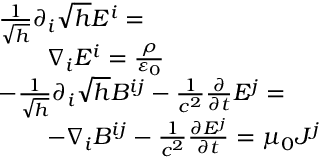Convert formula to latex. <formula><loc_0><loc_0><loc_500><loc_500>{ \begin{array} { r l } & { { \frac { 1 } { \sqrt { h } } } \partial _ { i } { \sqrt { h } } E ^ { i } = } \\ & { \quad \nabla _ { i } E ^ { i } = { \frac { \rho } { \varepsilon _ { 0 } } } } \\ & { { - } { \frac { 1 } { \sqrt { h } } } \partial _ { i } { \sqrt { h } } B ^ { i j } - { \frac { 1 } { c ^ { 2 } } } { \frac { \partial } { \partial t } } E ^ { j } = } \\ & { \quad { - } \nabla _ { i } B ^ { i j } - { \frac { 1 } { c ^ { 2 } } } { \frac { \partial E ^ { j } } { \partial t } } = \mu _ { 0 } J ^ { j } } \end{array} }</formula> 